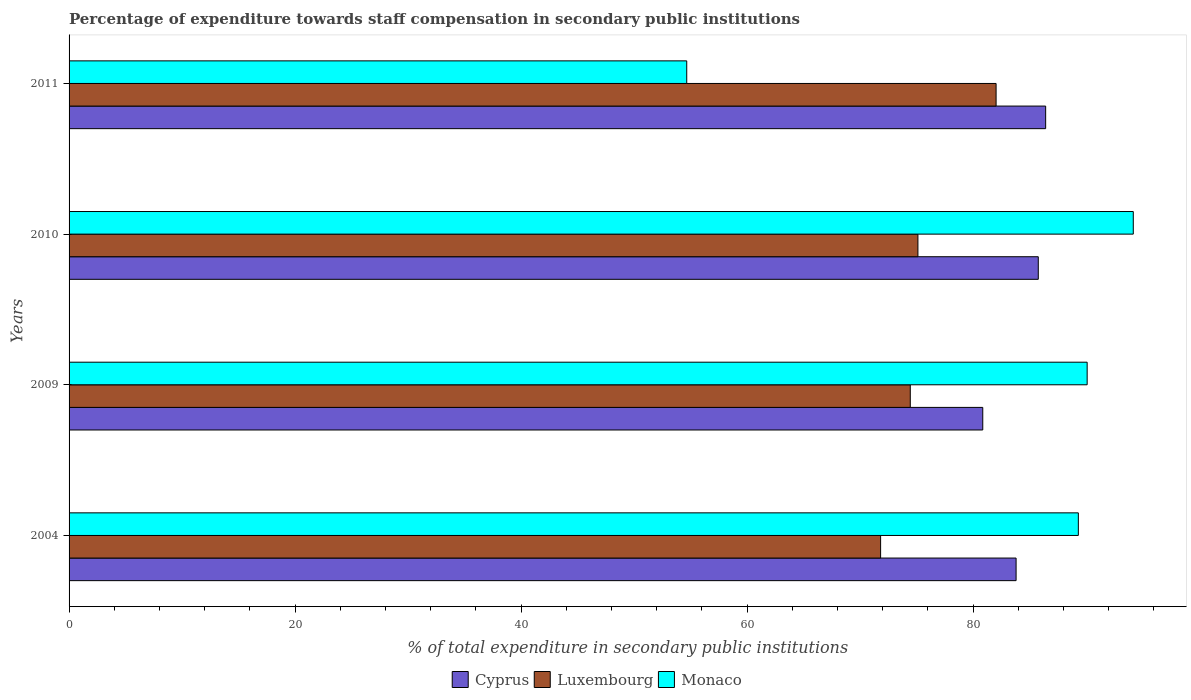How many different coloured bars are there?
Offer a terse response. 3. Are the number of bars on each tick of the Y-axis equal?
Provide a short and direct response. Yes. How many bars are there on the 1st tick from the top?
Provide a short and direct response. 3. In how many cases, is the number of bars for a given year not equal to the number of legend labels?
Provide a succinct answer. 0. What is the percentage of expenditure towards staff compensation in Cyprus in 2004?
Provide a short and direct response. 83.8. Across all years, what is the maximum percentage of expenditure towards staff compensation in Cyprus?
Give a very brief answer. 86.42. Across all years, what is the minimum percentage of expenditure towards staff compensation in Luxembourg?
Make the answer very short. 71.81. What is the total percentage of expenditure towards staff compensation in Monaco in the graph?
Keep it short and to the point. 328.22. What is the difference between the percentage of expenditure towards staff compensation in Cyprus in 2004 and that in 2010?
Your answer should be very brief. -1.96. What is the difference between the percentage of expenditure towards staff compensation in Monaco in 2004 and the percentage of expenditure towards staff compensation in Cyprus in 2009?
Provide a succinct answer. 8.46. What is the average percentage of expenditure towards staff compensation in Cyprus per year?
Provide a succinct answer. 84.21. In the year 2009, what is the difference between the percentage of expenditure towards staff compensation in Monaco and percentage of expenditure towards staff compensation in Cyprus?
Keep it short and to the point. 9.24. What is the ratio of the percentage of expenditure towards staff compensation in Luxembourg in 2004 to that in 2010?
Offer a terse response. 0.96. Is the difference between the percentage of expenditure towards staff compensation in Monaco in 2009 and 2010 greater than the difference between the percentage of expenditure towards staff compensation in Cyprus in 2009 and 2010?
Offer a terse response. Yes. What is the difference between the highest and the second highest percentage of expenditure towards staff compensation in Luxembourg?
Your answer should be compact. 6.92. What is the difference between the highest and the lowest percentage of expenditure towards staff compensation in Luxembourg?
Make the answer very short. 10.22. Is the sum of the percentage of expenditure towards staff compensation in Cyprus in 2010 and 2011 greater than the maximum percentage of expenditure towards staff compensation in Monaco across all years?
Offer a terse response. Yes. What does the 1st bar from the top in 2004 represents?
Offer a very short reply. Monaco. What does the 1st bar from the bottom in 2011 represents?
Keep it short and to the point. Cyprus. Is it the case that in every year, the sum of the percentage of expenditure towards staff compensation in Cyprus and percentage of expenditure towards staff compensation in Monaco is greater than the percentage of expenditure towards staff compensation in Luxembourg?
Offer a very short reply. Yes. Are all the bars in the graph horizontal?
Offer a terse response. Yes. How many years are there in the graph?
Provide a short and direct response. 4. Are the values on the major ticks of X-axis written in scientific E-notation?
Provide a short and direct response. No. Does the graph contain any zero values?
Your answer should be compact. No. Does the graph contain grids?
Your answer should be compact. No. What is the title of the graph?
Keep it short and to the point. Percentage of expenditure towards staff compensation in secondary public institutions. Does "European Union" appear as one of the legend labels in the graph?
Your answer should be very brief. No. What is the label or title of the X-axis?
Keep it short and to the point. % of total expenditure in secondary public institutions. What is the % of total expenditure in secondary public institutions in Cyprus in 2004?
Ensure brevity in your answer.  83.8. What is the % of total expenditure in secondary public institutions in Luxembourg in 2004?
Provide a succinct answer. 71.81. What is the % of total expenditure in secondary public institutions in Monaco in 2004?
Offer a very short reply. 89.31. What is the % of total expenditure in secondary public institutions of Cyprus in 2009?
Your answer should be very brief. 80.85. What is the % of total expenditure in secondary public institutions of Luxembourg in 2009?
Your answer should be compact. 74.44. What is the % of total expenditure in secondary public institutions in Monaco in 2009?
Ensure brevity in your answer.  90.09. What is the % of total expenditure in secondary public institutions in Cyprus in 2010?
Provide a short and direct response. 85.76. What is the % of total expenditure in secondary public institutions in Luxembourg in 2010?
Make the answer very short. 75.11. What is the % of total expenditure in secondary public institutions in Monaco in 2010?
Make the answer very short. 94.17. What is the % of total expenditure in secondary public institutions in Cyprus in 2011?
Provide a short and direct response. 86.42. What is the % of total expenditure in secondary public institutions of Luxembourg in 2011?
Your answer should be very brief. 82.03. What is the % of total expenditure in secondary public institutions of Monaco in 2011?
Your answer should be compact. 54.66. Across all years, what is the maximum % of total expenditure in secondary public institutions of Cyprus?
Provide a short and direct response. 86.42. Across all years, what is the maximum % of total expenditure in secondary public institutions in Luxembourg?
Offer a very short reply. 82.03. Across all years, what is the maximum % of total expenditure in secondary public institutions of Monaco?
Your answer should be very brief. 94.17. Across all years, what is the minimum % of total expenditure in secondary public institutions of Cyprus?
Provide a short and direct response. 80.85. Across all years, what is the minimum % of total expenditure in secondary public institutions in Luxembourg?
Make the answer very short. 71.81. Across all years, what is the minimum % of total expenditure in secondary public institutions of Monaco?
Ensure brevity in your answer.  54.66. What is the total % of total expenditure in secondary public institutions of Cyprus in the graph?
Give a very brief answer. 336.83. What is the total % of total expenditure in secondary public institutions of Luxembourg in the graph?
Offer a very short reply. 303.39. What is the total % of total expenditure in secondary public institutions in Monaco in the graph?
Ensure brevity in your answer.  328.22. What is the difference between the % of total expenditure in secondary public institutions in Cyprus in 2004 and that in 2009?
Offer a very short reply. 2.95. What is the difference between the % of total expenditure in secondary public institutions in Luxembourg in 2004 and that in 2009?
Offer a terse response. -2.63. What is the difference between the % of total expenditure in secondary public institutions of Monaco in 2004 and that in 2009?
Offer a terse response. -0.78. What is the difference between the % of total expenditure in secondary public institutions in Cyprus in 2004 and that in 2010?
Keep it short and to the point. -1.96. What is the difference between the % of total expenditure in secondary public institutions in Luxembourg in 2004 and that in 2010?
Provide a succinct answer. -3.3. What is the difference between the % of total expenditure in secondary public institutions of Monaco in 2004 and that in 2010?
Offer a terse response. -4.86. What is the difference between the % of total expenditure in secondary public institutions of Cyprus in 2004 and that in 2011?
Provide a succinct answer. -2.62. What is the difference between the % of total expenditure in secondary public institutions in Luxembourg in 2004 and that in 2011?
Keep it short and to the point. -10.22. What is the difference between the % of total expenditure in secondary public institutions in Monaco in 2004 and that in 2011?
Your answer should be compact. 34.65. What is the difference between the % of total expenditure in secondary public institutions of Cyprus in 2009 and that in 2010?
Give a very brief answer. -4.91. What is the difference between the % of total expenditure in secondary public institutions in Luxembourg in 2009 and that in 2010?
Offer a terse response. -0.68. What is the difference between the % of total expenditure in secondary public institutions of Monaco in 2009 and that in 2010?
Make the answer very short. -4.08. What is the difference between the % of total expenditure in secondary public institutions of Cyprus in 2009 and that in 2011?
Your response must be concise. -5.57. What is the difference between the % of total expenditure in secondary public institutions in Luxembourg in 2009 and that in 2011?
Provide a succinct answer. -7.59. What is the difference between the % of total expenditure in secondary public institutions of Monaco in 2009 and that in 2011?
Offer a terse response. 35.43. What is the difference between the % of total expenditure in secondary public institutions in Cyprus in 2010 and that in 2011?
Provide a short and direct response. -0.65. What is the difference between the % of total expenditure in secondary public institutions in Luxembourg in 2010 and that in 2011?
Your answer should be compact. -6.92. What is the difference between the % of total expenditure in secondary public institutions of Monaco in 2010 and that in 2011?
Offer a very short reply. 39.51. What is the difference between the % of total expenditure in secondary public institutions in Cyprus in 2004 and the % of total expenditure in secondary public institutions in Luxembourg in 2009?
Your response must be concise. 9.36. What is the difference between the % of total expenditure in secondary public institutions of Cyprus in 2004 and the % of total expenditure in secondary public institutions of Monaco in 2009?
Offer a very short reply. -6.29. What is the difference between the % of total expenditure in secondary public institutions of Luxembourg in 2004 and the % of total expenditure in secondary public institutions of Monaco in 2009?
Your answer should be compact. -18.28. What is the difference between the % of total expenditure in secondary public institutions in Cyprus in 2004 and the % of total expenditure in secondary public institutions in Luxembourg in 2010?
Your answer should be compact. 8.69. What is the difference between the % of total expenditure in secondary public institutions of Cyprus in 2004 and the % of total expenditure in secondary public institutions of Monaco in 2010?
Give a very brief answer. -10.37. What is the difference between the % of total expenditure in secondary public institutions of Luxembourg in 2004 and the % of total expenditure in secondary public institutions of Monaco in 2010?
Offer a very short reply. -22.36. What is the difference between the % of total expenditure in secondary public institutions of Cyprus in 2004 and the % of total expenditure in secondary public institutions of Luxembourg in 2011?
Ensure brevity in your answer.  1.77. What is the difference between the % of total expenditure in secondary public institutions of Cyprus in 2004 and the % of total expenditure in secondary public institutions of Monaco in 2011?
Give a very brief answer. 29.14. What is the difference between the % of total expenditure in secondary public institutions of Luxembourg in 2004 and the % of total expenditure in secondary public institutions of Monaco in 2011?
Your answer should be very brief. 17.16. What is the difference between the % of total expenditure in secondary public institutions of Cyprus in 2009 and the % of total expenditure in secondary public institutions of Luxembourg in 2010?
Keep it short and to the point. 5.74. What is the difference between the % of total expenditure in secondary public institutions in Cyprus in 2009 and the % of total expenditure in secondary public institutions in Monaco in 2010?
Give a very brief answer. -13.32. What is the difference between the % of total expenditure in secondary public institutions of Luxembourg in 2009 and the % of total expenditure in secondary public institutions of Monaco in 2010?
Your answer should be compact. -19.73. What is the difference between the % of total expenditure in secondary public institutions of Cyprus in 2009 and the % of total expenditure in secondary public institutions of Luxembourg in 2011?
Ensure brevity in your answer.  -1.18. What is the difference between the % of total expenditure in secondary public institutions in Cyprus in 2009 and the % of total expenditure in secondary public institutions in Monaco in 2011?
Ensure brevity in your answer.  26.19. What is the difference between the % of total expenditure in secondary public institutions of Luxembourg in 2009 and the % of total expenditure in secondary public institutions of Monaco in 2011?
Provide a short and direct response. 19.78. What is the difference between the % of total expenditure in secondary public institutions in Cyprus in 2010 and the % of total expenditure in secondary public institutions in Luxembourg in 2011?
Your response must be concise. 3.73. What is the difference between the % of total expenditure in secondary public institutions of Cyprus in 2010 and the % of total expenditure in secondary public institutions of Monaco in 2011?
Keep it short and to the point. 31.11. What is the difference between the % of total expenditure in secondary public institutions of Luxembourg in 2010 and the % of total expenditure in secondary public institutions of Monaco in 2011?
Your answer should be compact. 20.46. What is the average % of total expenditure in secondary public institutions in Cyprus per year?
Offer a terse response. 84.21. What is the average % of total expenditure in secondary public institutions of Luxembourg per year?
Keep it short and to the point. 75.85. What is the average % of total expenditure in secondary public institutions in Monaco per year?
Your answer should be compact. 82.06. In the year 2004, what is the difference between the % of total expenditure in secondary public institutions in Cyprus and % of total expenditure in secondary public institutions in Luxembourg?
Your answer should be very brief. 11.99. In the year 2004, what is the difference between the % of total expenditure in secondary public institutions of Cyprus and % of total expenditure in secondary public institutions of Monaco?
Offer a very short reply. -5.51. In the year 2004, what is the difference between the % of total expenditure in secondary public institutions in Luxembourg and % of total expenditure in secondary public institutions in Monaco?
Ensure brevity in your answer.  -17.5. In the year 2009, what is the difference between the % of total expenditure in secondary public institutions in Cyprus and % of total expenditure in secondary public institutions in Luxembourg?
Offer a terse response. 6.41. In the year 2009, what is the difference between the % of total expenditure in secondary public institutions in Cyprus and % of total expenditure in secondary public institutions in Monaco?
Your answer should be very brief. -9.24. In the year 2009, what is the difference between the % of total expenditure in secondary public institutions in Luxembourg and % of total expenditure in secondary public institutions in Monaco?
Offer a terse response. -15.65. In the year 2010, what is the difference between the % of total expenditure in secondary public institutions in Cyprus and % of total expenditure in secondary public institutions in Luxembourg?
Keep it short and to the point. 10.65. In the year 2010, what is the difference between the % of total expenditure in secondary public institutions in Cyprus and % of total expenditure in secondary public institutions in Monaco?
Provide a short and direct response. -8.41. In the year 2010, what is the difference between the % of total expenditure in secondary public institutions in Luxembourg and % of total expenditure in secondary public institutions in Monaco?
Ensure brevity in your answer.  -19.06. In the year 2011, what is the difference between the % of total expenditure in secondary public institutions in Cyprus and % of total expenditure in secondary public institutions in Luxembourg?
Your answer should be compact. 4.39. In the year 2011, what is the difference between the % of total expenditure in secondary public institutions in Cyprus and % of total expenditure in secondary public institutions in Monaco?
Ensure brevity in your answer.  31.76. In the year 2011, what is the difference between the % of total expenditure in secondary public institutions of Luxembourg and % of total expenditure in secondary public institutions of Monaco?
Offer a terse response. 27.37. What is the ratio of the % of total expenditure in secondary public institutions of Cyprus in 2004 to that in 2009?
Make the answer very short. 1.04. What is the ratio of the % of total expenditure in secondary public institutions of Luxembourg in 2004 to that in 2009?
Give a very brief answer. 0.96. What is the ratio of the % of total expenditure in secondary public institutions of Monaco in 2004 to that in 2009?
Make the answer very short. 0.99. What is the ratio of the % of total expenditure in secondary public institutions of Cyprus in 2004 to that in 2010?
Offer a terse response. 0.98. What is the ratio of the % of total expenditure in secondary public institutions of Luxembourg in 2004 to that in 2010?
Your answer should be very brief. 0.96. What is the ratio of the % of total expenditure in secondary public institutions in Monaco in 2004 to that in 2010?
Ensure brevity in your answer.  0.95. What is the ratio of the % of total expenditure in secondary public institutions in Cyprus in 2004 to that in 2011?
Offer a very short reply. 0.97. What is the ratio of the % of total expenditure in secondary public institutions in Luxembourg in 2004 to that in 2011?
Offer a very short reply. 0.88. What is the ratio of the % of total expenditure in secondary public institutions of Monaco in 2004 to that in 2011?
Your answer should be compact. 1.63. What is the ratio of the % of total expenditure in secondary public institutions of Cyprus in 2009 to that in 2010?
Your response must be concise. 0.94. What is the ratio of the % of total expenditure in secondary public institutions in Luxembourg in 2009 to that in 2010?
Ensure brevity in your answer.  0.99. What is the ratio of the % of total expenditure in secondary public institutions in Monaco in 2009 to that in 2010?
Your answer should be compact. 0.96. What is the ratio of the % of total expenditure in secondary public institutions of Cyprus in 2009 to that in 2011?
Ensure brevity in your answer.  0.94. What is the ratio of the % of total expenditure in secondary public institutions of Luxembourg in 2009 to that in 2011?
Keep it short and to the point. 0.91. What is the ratio of the % of total expenditure in secondary public institutions of Monaco in 2009 to that in 2011?
Your response must be concise. 1.65. What is the ratio of the % of total expenditure in secondary public institutions of Cyprus in 2010 to that in 2011?
Keep it short and to the point. 0.99. What is the ratio of the % of total expenditure in secondary public institutions in Luxembourg in 2010 to that in 2011?
Your answer should be very brief. 0.92. What is the ratio of the % of total expenditure in secondary public institutions of Monaco in 2010 to that in 2011?
Offer a very short reply. 1.72. What is the difference between the highest and the second highest % of total expenditure in secondary public institutions of Cyprus?
Ensure brevity in your answer.  0.65. What is the difference between the highest and the second highest % of total expenditure in secondary public institutions in Luxembourg?
Your response must be concise. 6.92. What is the difference between the highest and the second highest % of total expenditure in secondary public institutions in Monaco?
Your answer should be compact. 4.08. What is the difference between the highest and the lowest % of total expenditure in secondary public institutions of Cyprus?
Provide a succinct answer. 5.57. What is the difference between the highest and the lowest % of total expenditure in secondary public institutions in Luxembourg?
Your response must be concise. 10.22. What is the difference between the highest and the lowest % of total expenditure in secondary public institutions in Monaco?
Your answer should be very brief. 39.51. 